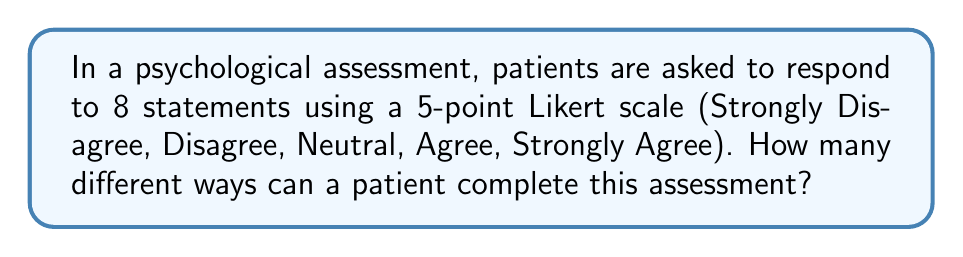Show me your answer to this math problem. Let's approach this step-by-step:

1) For each statement, the patient has 5 possible responses (the 5 points on the Likert scale).

2) The patient must respond to all 8 statements.

3) The choices for each statement are independent of the choices for other statements.

4) This scenario is a perfect example of the Multiplication Principle in combinatorics.

5) According to the Multiplication Principle, if we have a series of $n$ independent events, and each event $i$ has $m_i$ possible outcomes, then the total number of possible outcomes for all events is:

   $$\prod_{i=1}^n m_i$$

6) In our case, we have 8 events (statements), and each event has 5 possible outcomes (response options).

7) Therefore, the total number of ways to complete the assessment is:

   $$5 \times 5 \times 5 \times 5 \times 5 \times 5 \times 5 \times 5 = 5^8$$

8) We can calculate this:

   $$5^8 = 390,625$$

Thus, there are 390,625 different ways a patient can complete this psychological assessment.
Answer: $5^8 = 390,625$ 